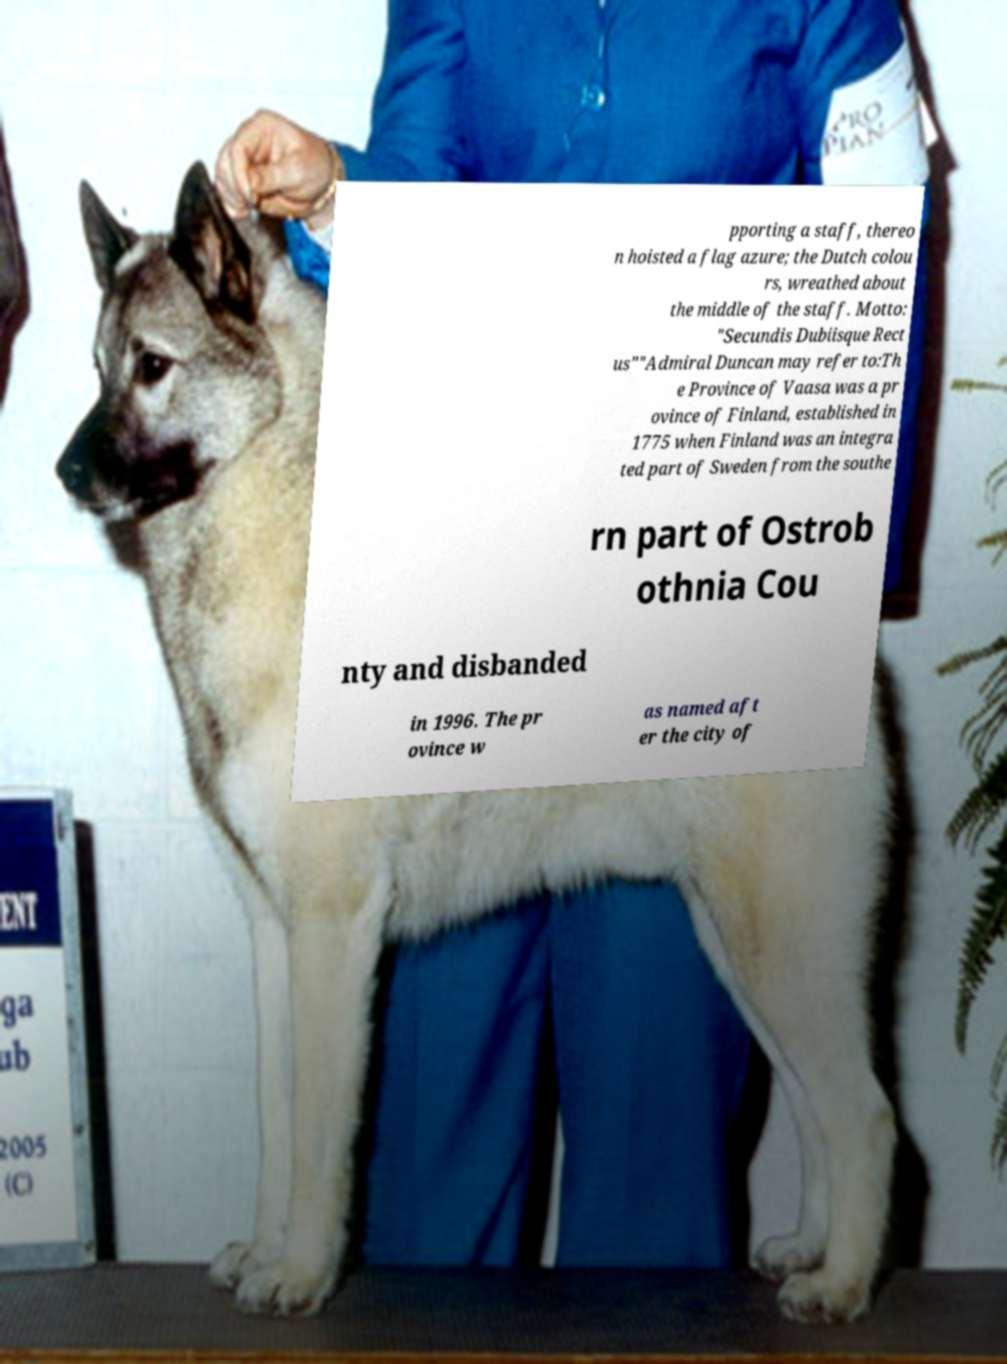I need the written content from this picture converted into text. Can you do that? pporting a staff, thereo n hoisted a flag azure; the Dutch colou rs, wreathed about the middle of the staff. Motto: "Secundis Dubiisque Rect us""Admiral Duncan may refer to:Th e Province of Vaasa was a pr ovince of Finland, established in 1775 when Finland was an integra ted part of Sweden from the southe rn part of Ostrob othnia Cou nty and disbanded in 1996. The pr ovince w as named aft er the city of 